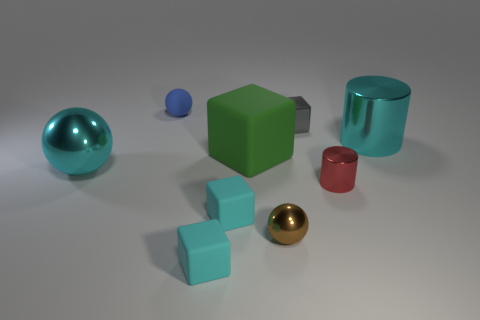Subtract all cyan cubes. How many were subtracted if there are1cyan cubes left? 1 Add 1 tiny metal cylinders. How many objects exist? 10 Subtract all cubes. How many objects are left? 5 Subtract 1 blue spheres. How many objects are left? 8 Subtract all tiny green rubber cylinders. Subtract all cyan blocks. How many objects are left? 7 Add 1 balls. How many balls are left? 4 Add 3 big gray matte objects. How many big gray matte objects exist? 3 